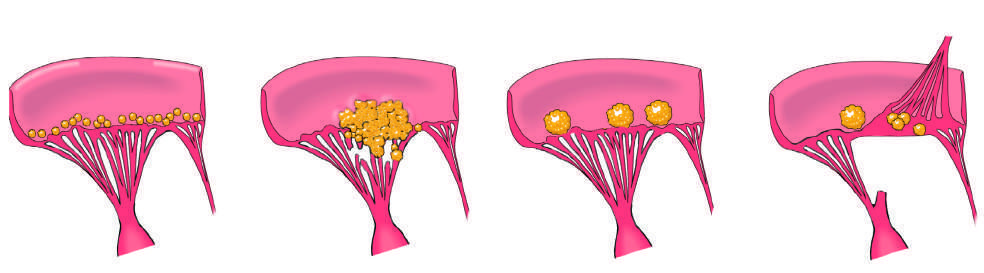s infective endocarditis characterized by large, irregular, often destructive masses that can extend from valve leaflets onto adjacent structures e.g., chordae or myocardium?
Answer the question using a single word or phrase. Yes 